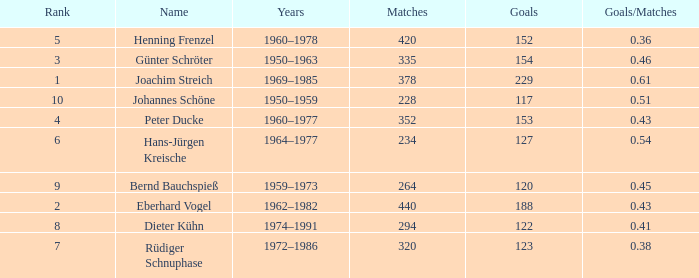How many goals/matches have 153 as the goals with matches greater than 352? None. 